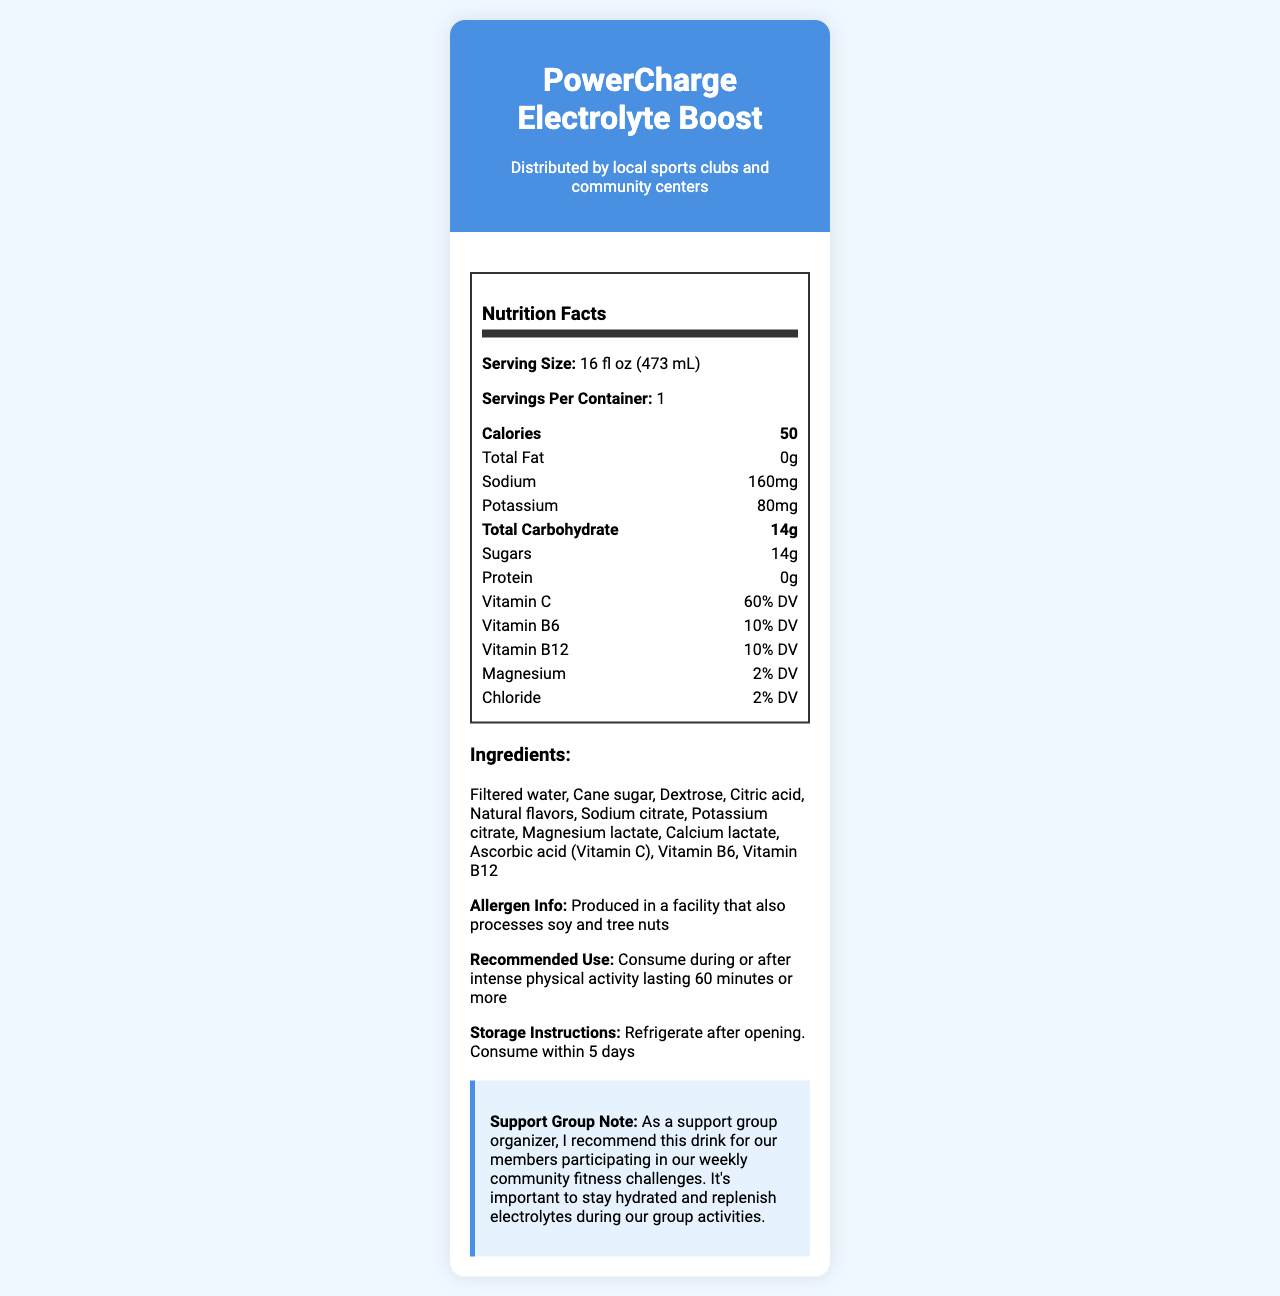what is the serving size of PowerCharge Electrolyte Boost? The serving size is clearly listed near the top of the nutrition label section.
Answer: 16 fl oz (473 mL) how many servings are there per container? This information is indicated right below the serving size.
Answer: 1 what is the calorie count per serving? The calorie count is shown prominently in the nutrition label.
Answer: 50 calories how much sodium does the sports drink contain? The sodium content is listed within the nutrition label under the total fat value.
Answer: 160mg what percentage of daily value of Vitamin C does the drink provide? The percentage daily value of Vitamin C is mentioned in the nutrition label section.
Answer: 60% DV which ingredients in the drink contribute to its electrolyte content? The ingredients list contains these specific compounds known for replenishing electrolytes.
Answer: Sodium citrate, Potassium citrate, Magnesium lactate, Calcium lactate how much total carbohydrate is present in one serving?  A. 10g B. 12g C. 14g The amount of total carbohydrate is shown in the nutrition label as 14g.
Answer: C what is the protein content of PowerCharge Electrolyte Boost? A. 1g B. 2g C. 0g D. 5g The protein content is listed in the nutrition label and is 0g.
Answer: C are any common allergens processed in the same facility as this sports drink? Allergen information stated that the product is produced in a facility that also processes soy and tree nuts.
Answer: Yes should this drink be consumed during or after light physical activity? The document recommends consuming the drink during or after intense physical activity lasting 60 minutes or more.
Answer: No summarize the main features of the nutrition facts label for PowerCharge Electrolyte Boost. This answer describes key nutritional components, serving recommendations, ingredients, and additional product notes.
Answer: The PowerCharge Electrolyte Boost is a sports drink designed for hydration and replenishment of electrolytes, especially during or after intense physical activities. It has a serving size of 16 fl oz (473 mL) and contains 50 calories per serving, with no fat or protein. Its key electrolytes include sodium (160mg), potassium (80mg), and a contribution of vitamins such as Vitamin C (60% DV), Vitamin B6, and Vitamin B12 (both 10% DV). The drink is made from ingredients like filtered water, cane sugar, dextrose, and various citrates aimed at electrolyte replenishment. It comes with specific storage instructions and a consumption recommendation. what is the main ingredient in PowerCharge Electrolyte Boost? The document lists all ingredients, but it does not specify which is the main ingredient.
Answer: Not enough information 